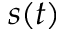Convert formula to latex. <formula><loc_0><loc_0><loc_500><loc_500>s ( t )</formula> 